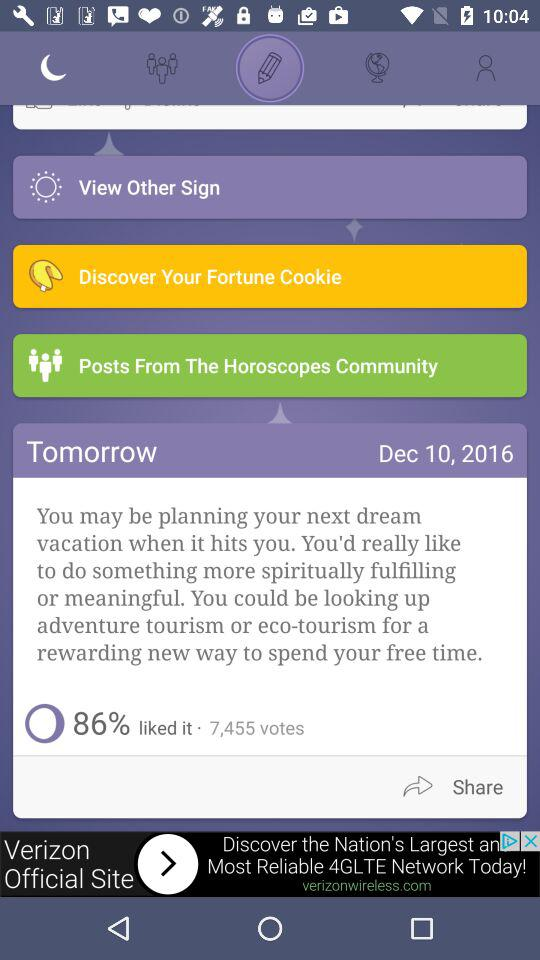What is tomorrow's date? The date is December 10, 2016. 